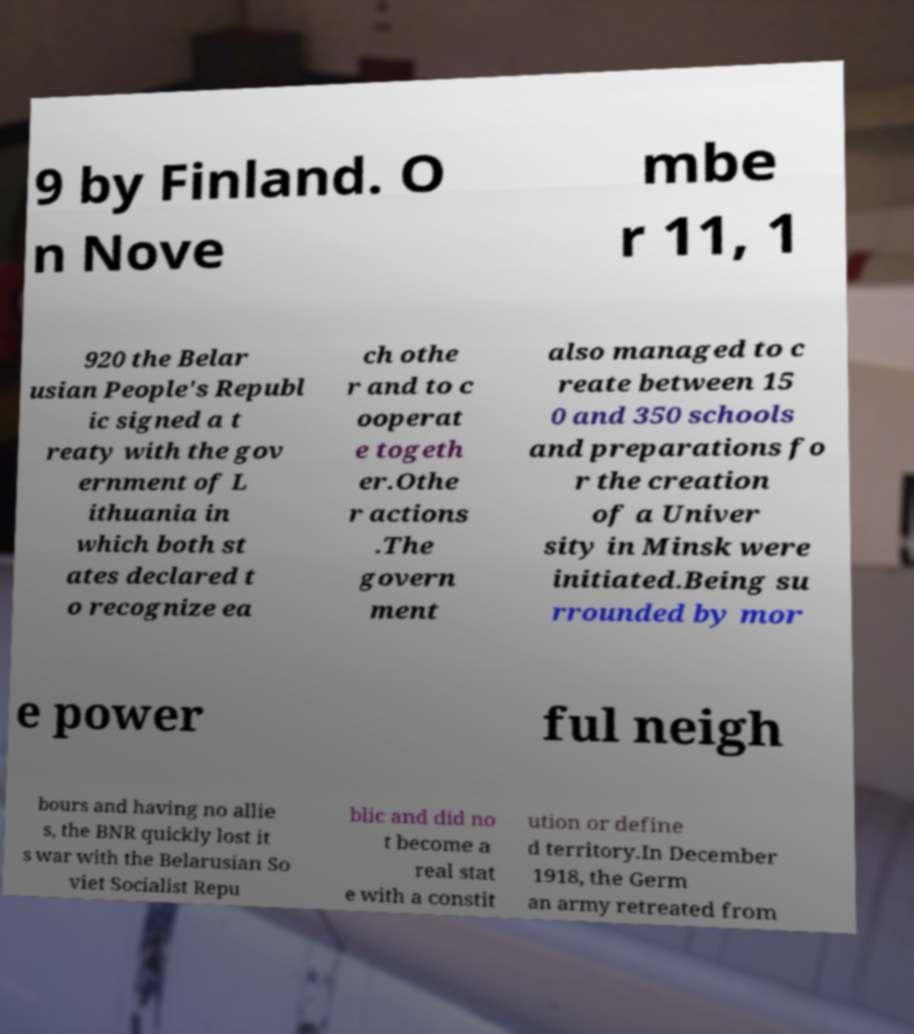Please read and relay the text visible in this image. What does it say? 9 by Finland. O n Nove mbe r 11, 1 920 the Belar usian People's Republ ic signed a t reaty with the gov ernment of L ithuania in which both st ates declared t o recognize ea ch othe r and to c ooperat e togeth er.Othe r actions .The govern ment also managed to c reate between 15 0 and 350 schools and preparations fo r the creation of a Univer sity in Minsk were initiated.Being su rrounded by mor e power ful neigh bours and having no allie s, the BNR quickly lost it s war with the Belarusian So viet Socialist Repu blic and did no t become a real stat e with a constit ution or define d territory.In December 1918, the Germ an army retreated from 